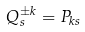<formula> <loc_0><loc_0><loc_500><loc_500>Q _ { s } ^ { \pm k } = P _ { k s }</formula> 